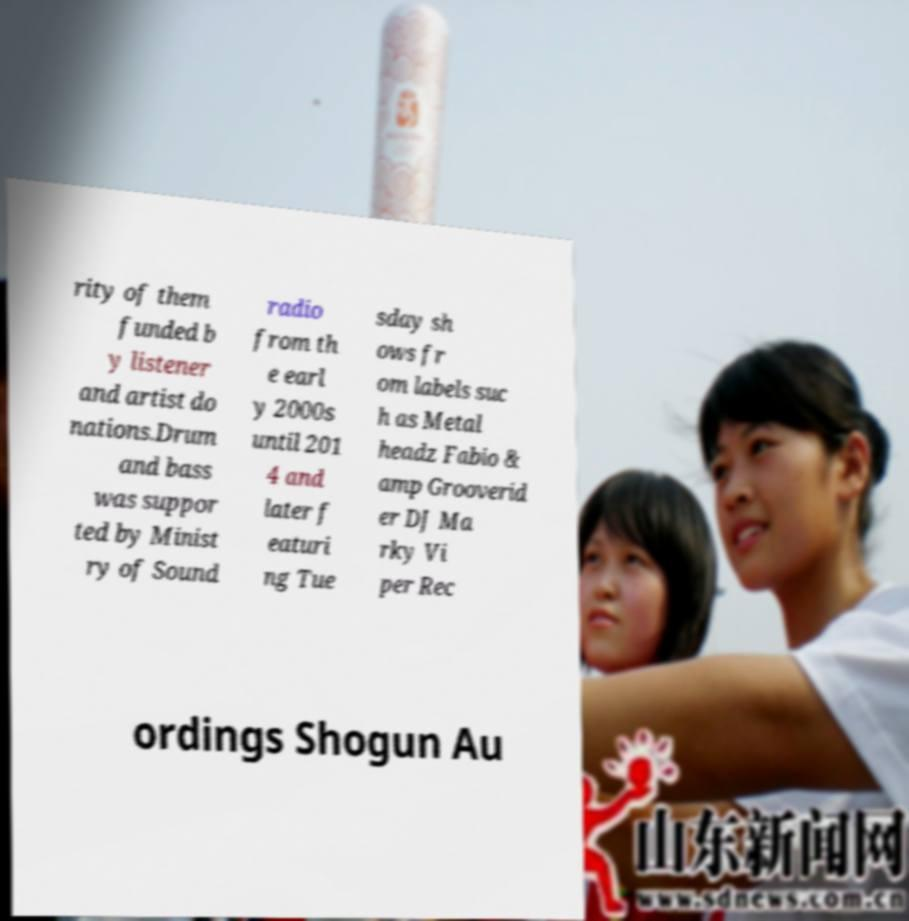There's text embedded in this image that I need extracted. Can you transcribe it verbatim? rity of them funded b y listener and artist do nations.Drum and bass was suppor ted by Minist ry of Sound radio from th e earl y 2000s until 201 4 and later f eaturi ng Tue sday sh ows fr om labels suc h as Metal headz Fabio & amp Grooverid er DJ Ma rky Vi per Rec ordings Shogun Au 